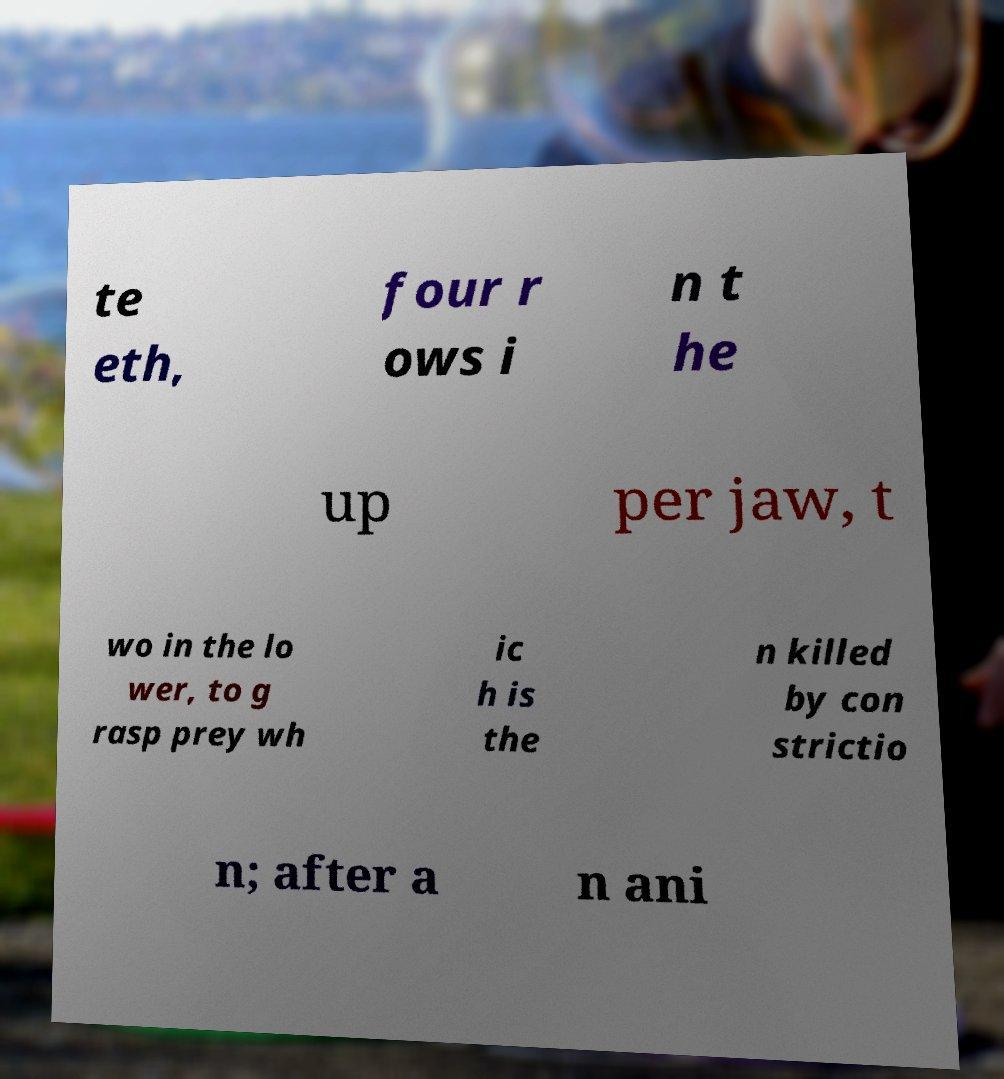Can you read and provide the text displayed in the image?This photo seems to have some interesting text. Can you extract and type it out for me? te eth, four r ows i n t he up per jaw, t wo in the lo wer, to g rasp prey wh ic h is the n killed by con strictio n; after a n ani 